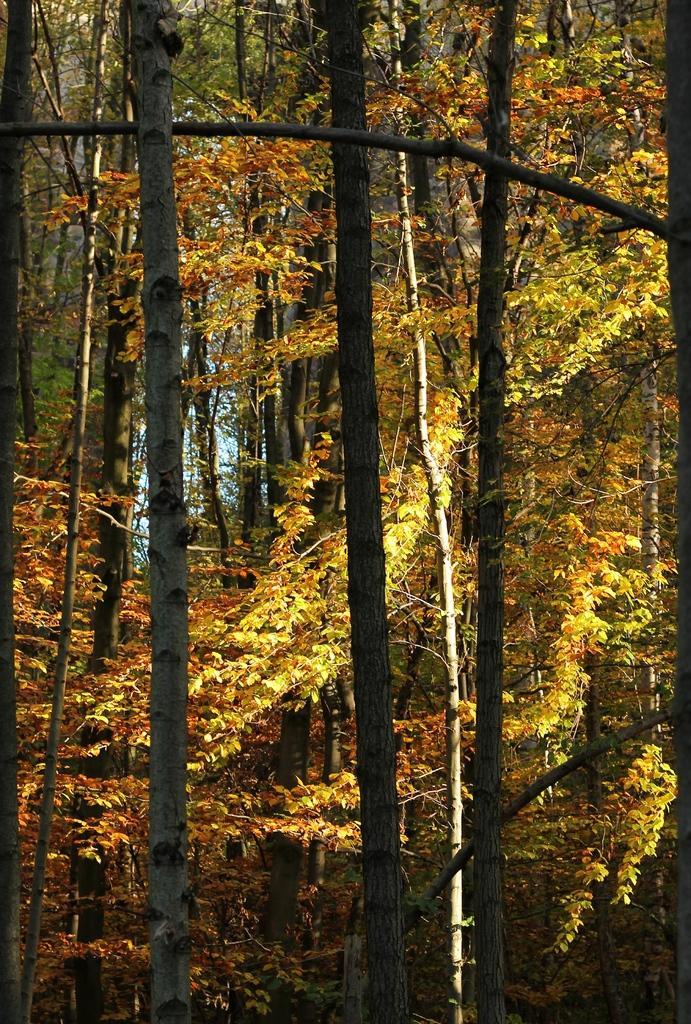Please provide a concise description of this image. In this image I see number of trees. 